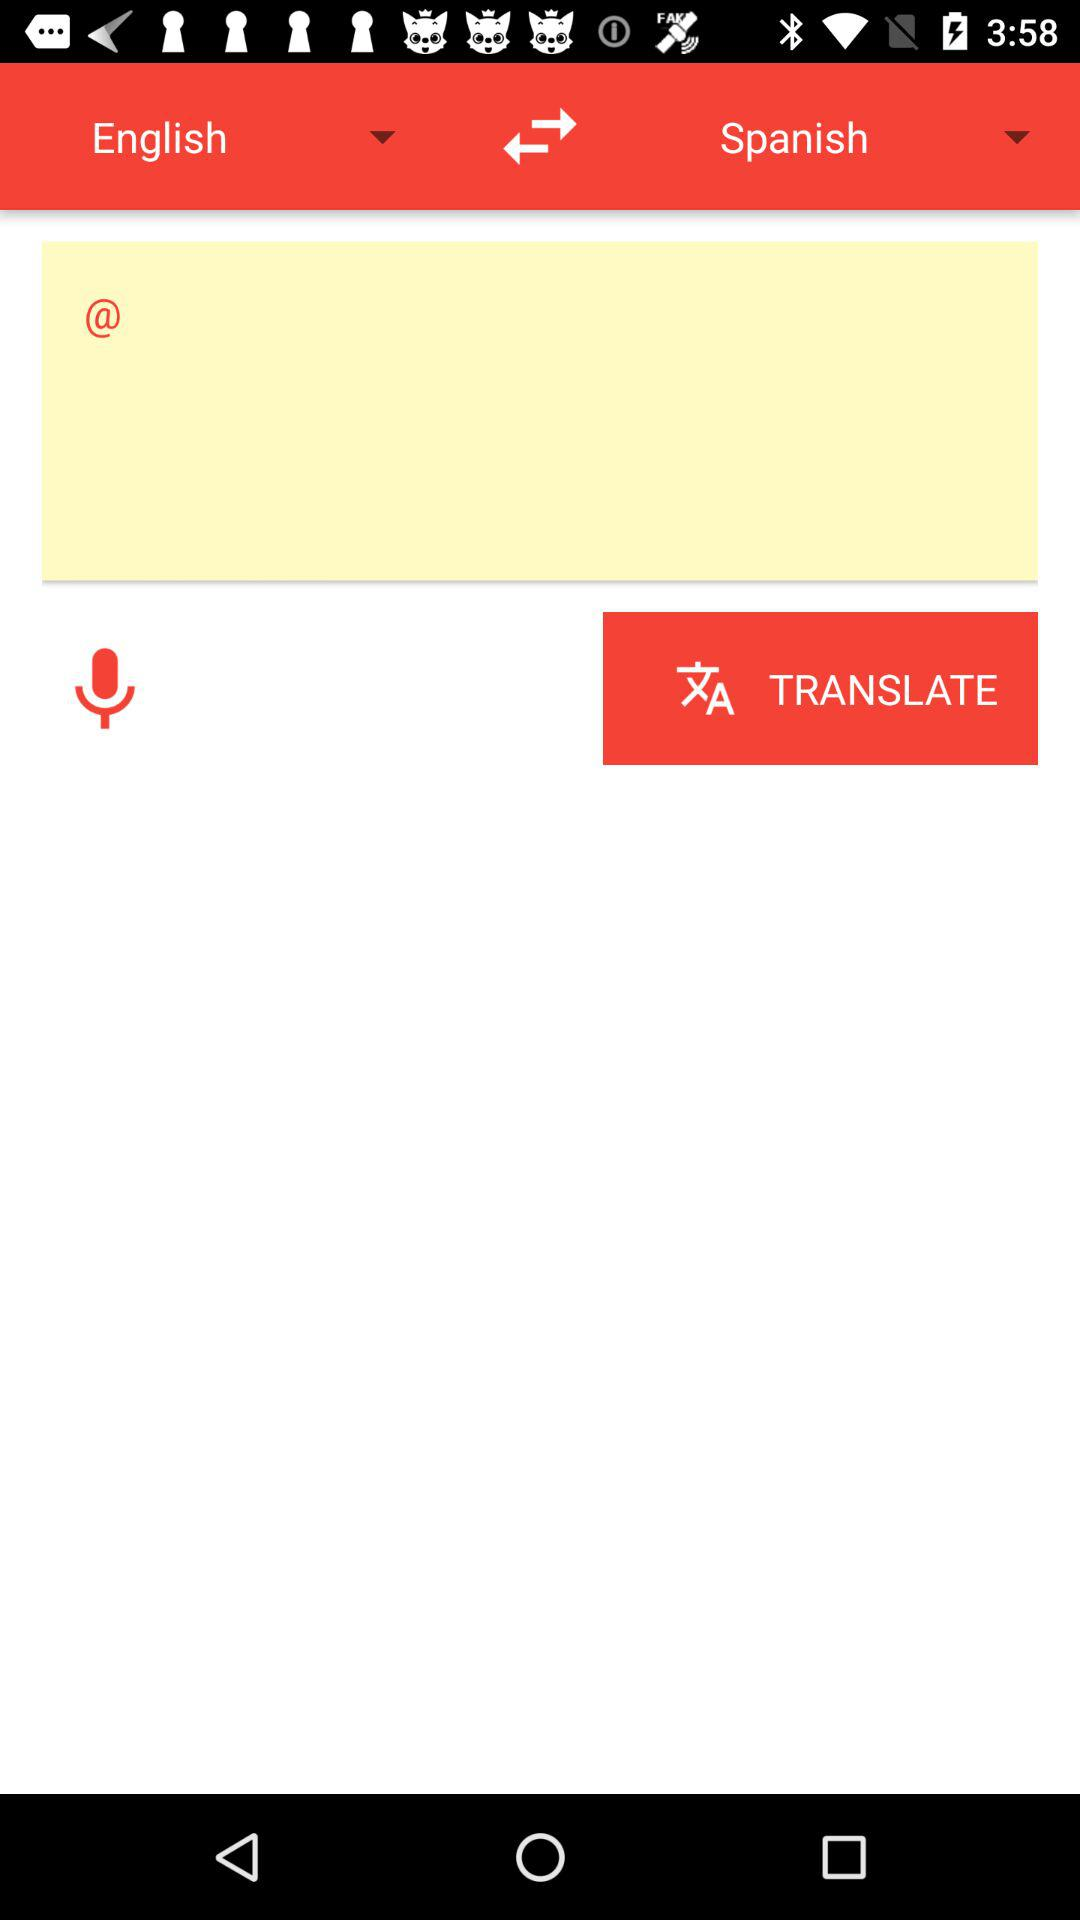How many languages are available to translate to?
Answer the question using a single word or phrase. 2 